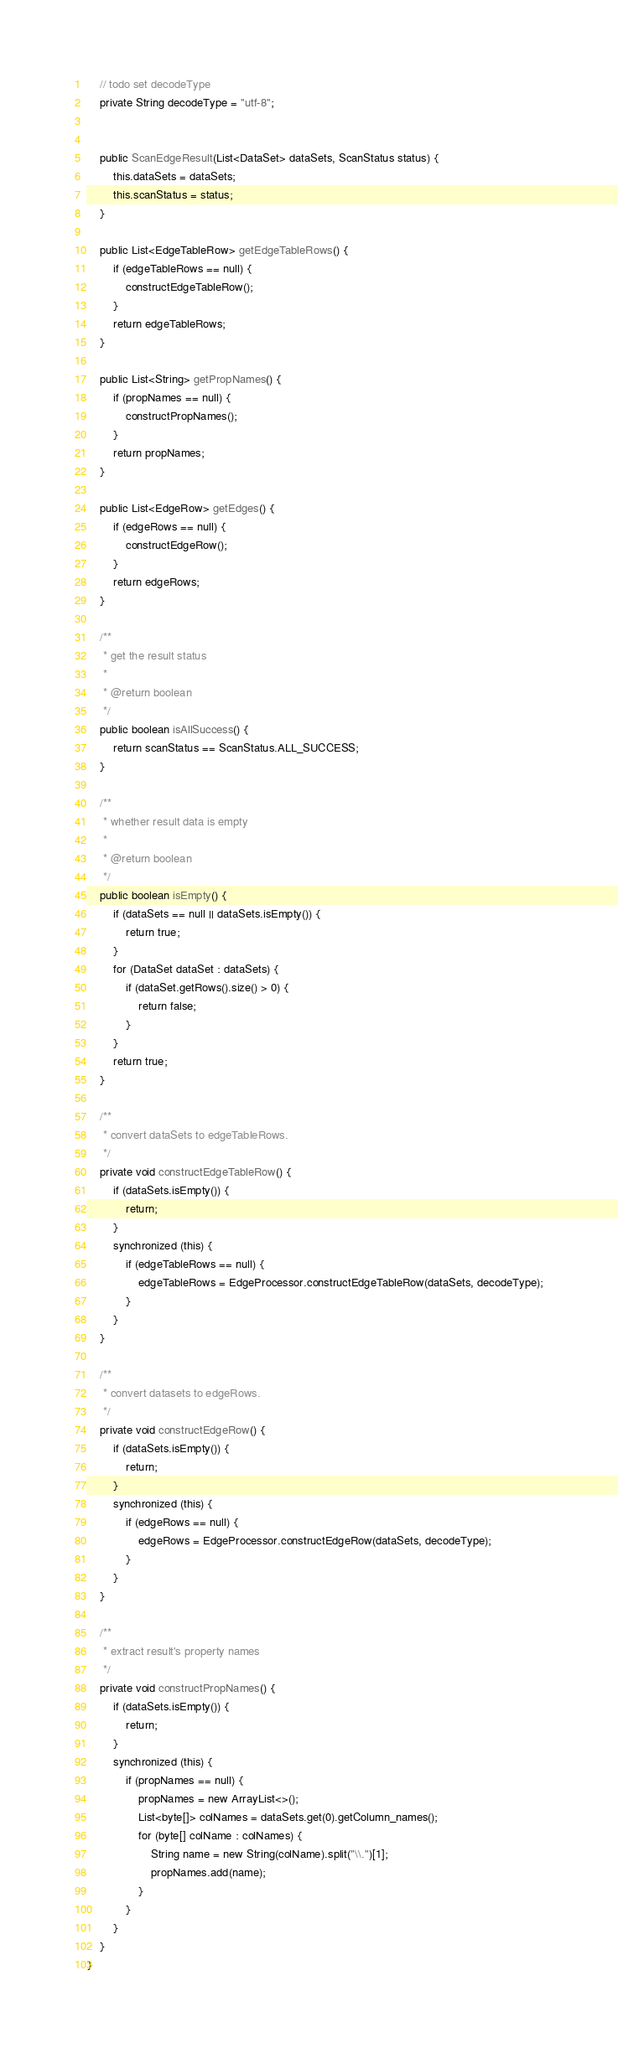<code> <loc_0><loc_0><loc_500><loc_500><_Java_>
    // todo set decodeType
    private String decodeType = "utf-8";


    public ScanEdgeResult(List<DataSet> dataSets, ScanStatus status) {
        this.dataSets = dataSets;
        this.scanStatus = status;
    }

    public List<EdgeTableRow> getEdgeTableRows() {
        if (edgeTableRows == null) {
            constructEdgeTableRow();
        }
        return edgeTableRows;
    }

    public List<String> getPropNames() {
        if (propNames == null) {
            constructPropNames();
        }
        return propNames;
    }

    public List<EdgeRow> getEdges() {
        if (edgeRows == null) {
            constructEdgeRow();
        }
        return edgeRows;
    }

    /**
     * get the result status
     *
     * @return boolean
     */
    public boolean isAllSuccess() {
        return scanStatus == ScanStatus.ALL_SUCCESS;
    }

    /**
     * whether result data is empty
     *
     * @return boolean
     */
    public boolean isEmpty() {
        if (dataSets == null || dataSets.isEmpty()) {
            return true;
        }
        for (DataSet dataSet : dataSets) {
            if (dataSet.getRows().size() > 0) {
                return false;
            }
        }
        return true;
    }

    /**
     * convert dataSets to edgeTableRows.
     */
    private void constructEdgeTableRow() {
        if (dataSets.isEmpty()) {
            return;
        }
        synchronized (this) {
            if (edgeTableRows == null) {
                edgeTableRows = EdgeProcessor.constructEdgeTableRow(dataSets, decodeType);
            }
        }
    }

    /**
     * convert datasets to edgeRows.
     */
    private void constructEdgeRow() {
        if (dataSets.isEmpty()) {
            return;
        }
        synchronized (this) {
            if (edgeRows == null) {
                edgeRows = EdgeProcessor.constructEdgeRow(dataSets, decodeType);
            }
        }
    }

    /**
     * extract result's property names
     */
    private void constructPropNames() {
        if (dataSets.isEmpty()) {
            return;
        }
        synchronized (this) {
            if (propNames == null) {
                propNames = new ArrayList<>();
                List<byte[]> colNames = dataSets.get(0).getColumn_names();
                for (byte[] colName : colNames) {
                    String name = new String(colName).split("\\.")[1];
                    propNames.add(name);
                }
            }
        }
    }
}
</code> 